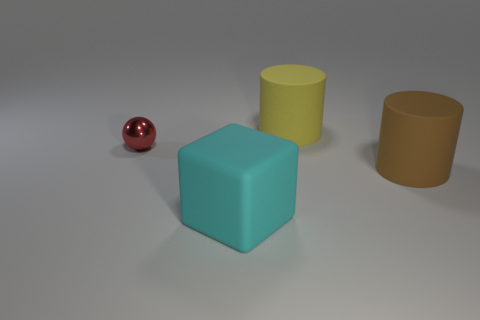Is there any other thing that is the same shape as the red object?
Keep it short and to the point. No. There is a matte object that is both in front of the yellow rubber object and left of the big brown cylinder; how big is it?
Your answer should be compact. Large. Is the number of big blocks behind the large brown matte cylinder the same as the number of tiny purple shiny cylinders?
Provide a short and direct response. Yes. Does the brown rubber cylinder have the same size as the rubber block?
Offer a terse response. Yes. What color is the big thing that is to the right of the block and in front of the large yellow cylinder?
Give a very brief answer. Brown. What is the material of the thing in front of the rubber cylinder that is in front of the sphere?
Offer a terse response. Rubber. Do the object that is to the right of the yellow matte thing and the metallic thing have the same color?
Give a very brief answer. No. Is the number of big brown rubber objects less than the number of yellow shiny cylinders?
Give a very brief answer. No. Are the object that is on the left side of the cyan matte thing and the brown cylinder made of the same material?
Offer a very short reply. No. What material is the big object behind the small red sphere?
Offer a very short reply. Rubber. 